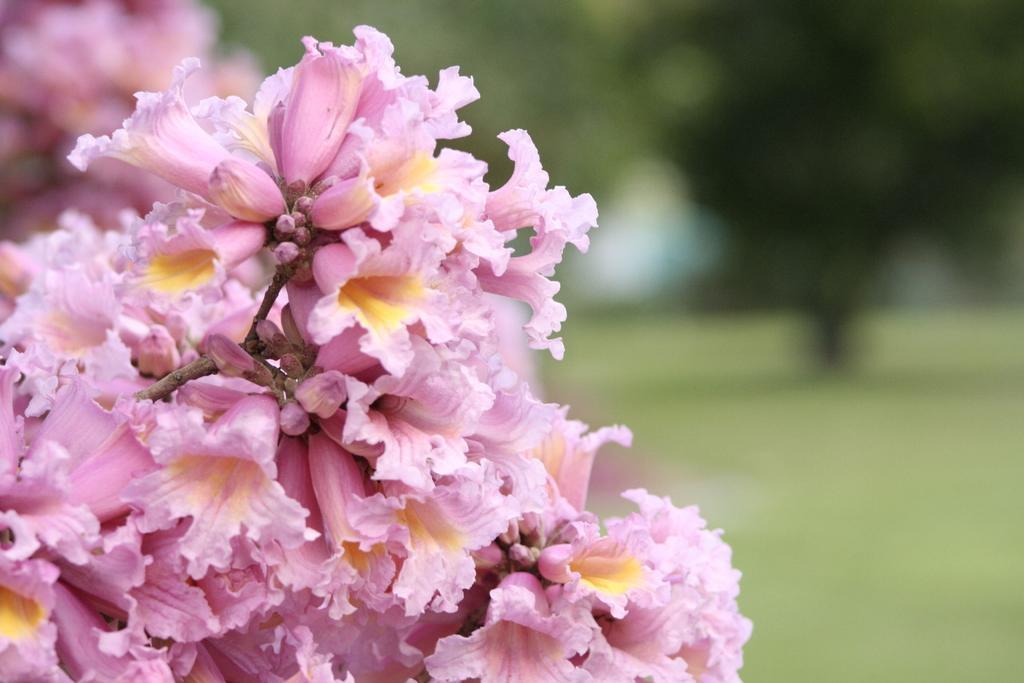In one or two sentences, can you explain what this image depicts? This image is taken outdoors. In this image the background is a little blurred. There are a few trees on the ground. There are a few flowers. On the left side of the image there are many flowers which are pink in color. On the right side of the image there is a ground with grass on it. 